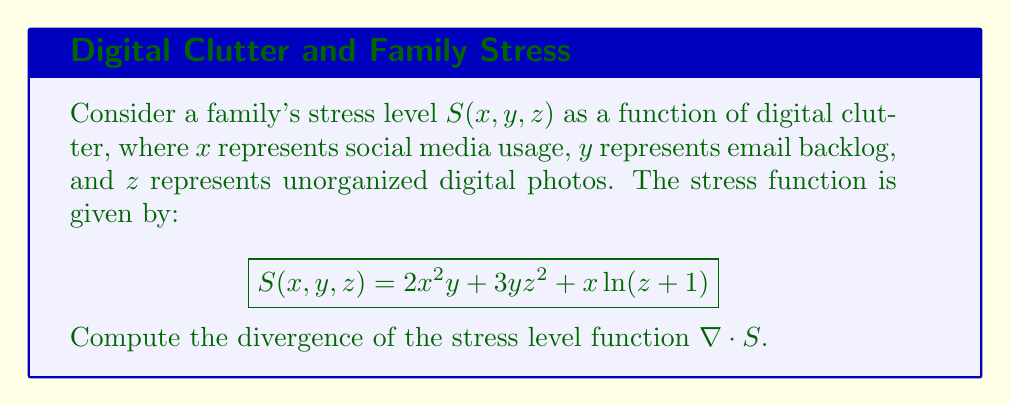Could you help me with this problem? To compute the divergence of the stress level function, we need to follow these steps:

1) The divergence of a scalar field $S(x, y, z)$ is defined as:

   $$\nabla \cdot S = \frac{\partial S}{\partial x} + \frac{\partial S}{\partial y} + \frac{\partial S}{\partial z}$$

2) Let's calculate each partial derivative:

   a) $\frac{\partial S}{\partial x}$:
      $$\frac{\partial S}{\partial x} = 4xy + \ln(z+1)$$

   b) $\frac{\partial S}{\partial y}$:
      $$\frac{\partial S}{\partial y} = 2x^2 + 3z^2$$

   c) $\frac{\partial S}{\partial z}$:
      $$\frac{\partial S}{\partial z} = 6yz + \frac{x}{z+1}$$

3) Now, we sum these partial derivatives to get the divergence:

   $$\nabla \cdot S = (4xy + \ln(z+1)) + (2x^2 + 3z^2) + (6yz + \frac{x}{z+1})$$

4) Simplify the expression:

   $$\nabla \cdot S = 4xy + 2x^2 + 3z^2 + 6yz + \ln(z+1) + \frac{x}{z+1}$$

This is the final expression for the divergence of the stress level function.
Answer: $$4xy + 2x^2 + 3z^2 + 6yz + \ln(z+1) + \frac{x}{z+1}$$ 